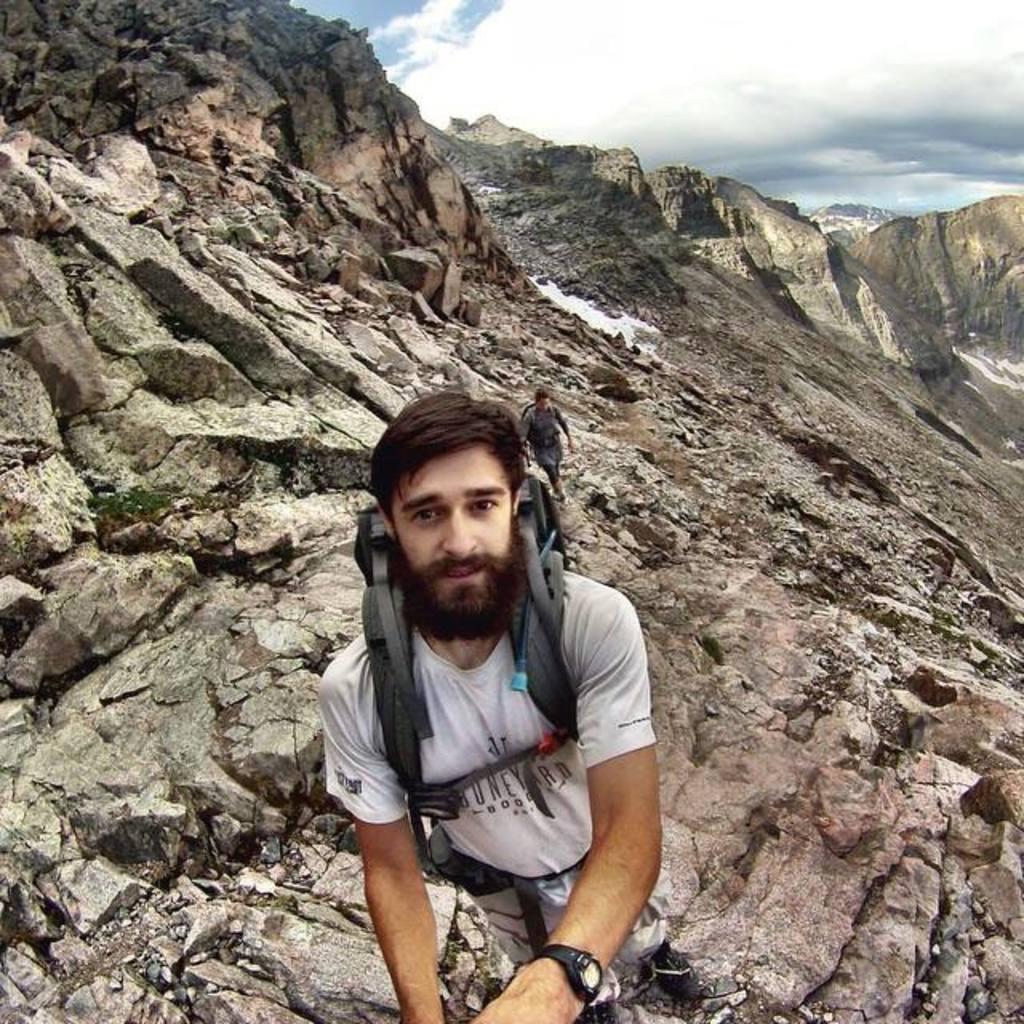Describe this image in one or two sentences. In this image we can see a man wearing a bag. We can also see another man in the background. Image also consists of rock hills. There is sky with the clouds. 